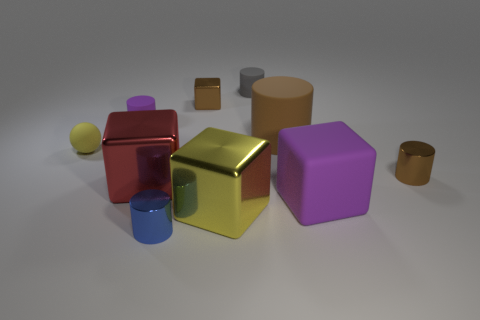Subtract 1 cylinders. How many cylinders are left? 4 Subtract all gray cylinders. How many cylinders are left? 4 Subtract all yellow cylinders. Subtract all yellow cubes. How many cylinders are left? 5 Subtract all spheres. How many objects are left? 9 Subtract all small purple metal cylinders. Subtract all small cylinders. How many objects are left? 6 Add 3 brown cylinders. How many brown cylinders are left? 5 Add 2 small gray cylinders. How many small gray cylinders exist? 3 Subtract 1 brown cubes. How many objects are left? 9 